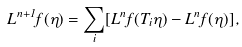Convert formula to latex. <formula><loc_0><loc_0><loc_500><loc_500>L ^ { n + 1 } f ( \eta ) = \sum _ { i } [ L ^ { n } f ( T _ { i } \eta ) - L ^ { n } f ( \eta ) ] ,</formula> 